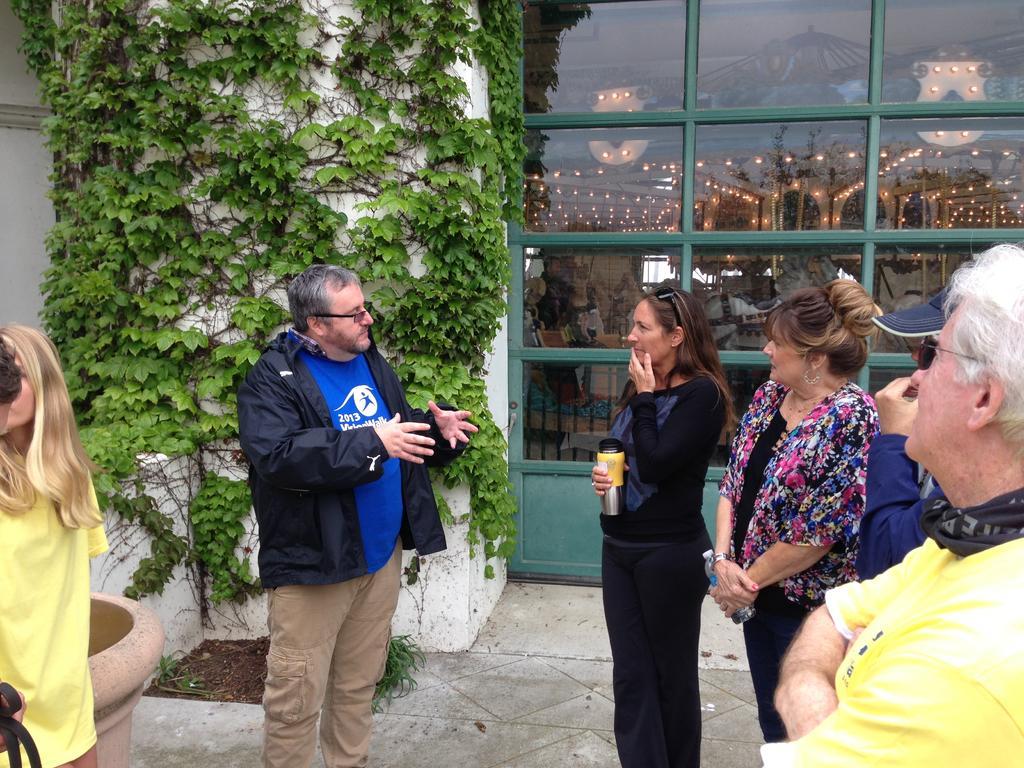Describe this image in one or two sentences. On the left side, there is a person in a blue color T-shirt, standing, a woman in a yellow color T-shirt, standing. Behind them, there are plants on a white colored pillar and there is a pot. On the right side, there are four persons standing. Two of them are holding bottles. In the background, there are glass windows. 